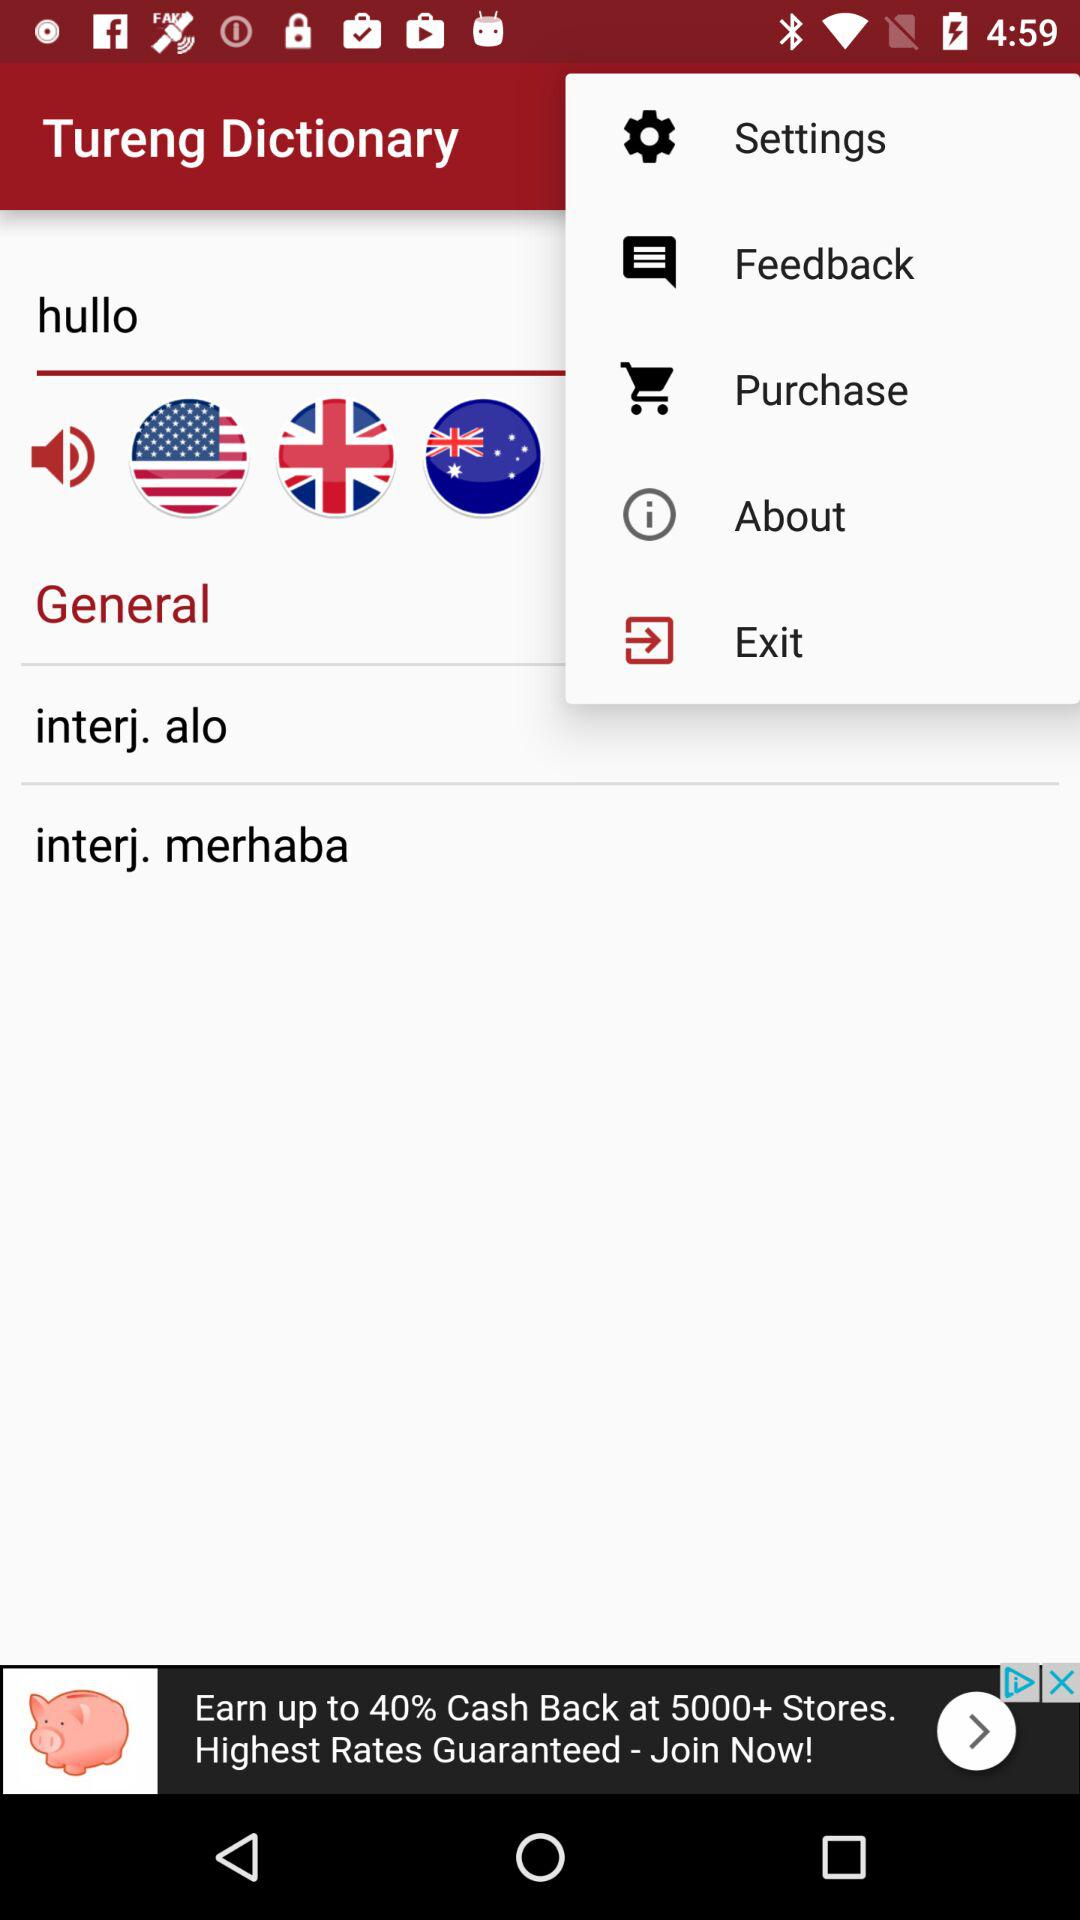What is the name of the application? The name of the application is "Tureng Dictionary". 